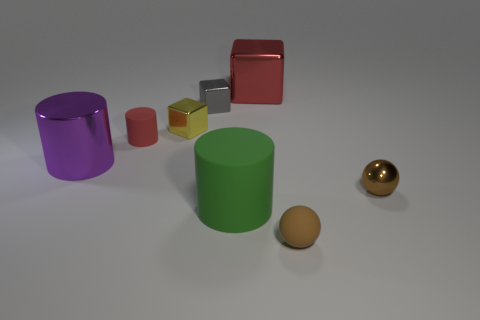There is a brown thing that is in front of the small sphere on the right side of the small brown matte object that is to the right of the red cylinder; what size is it?
Your answer should be very brief. Small. Is the tiny cylinder the same color as the shiny cylinder?
Provide a succinct answer. No. Is there anything else that is the same size as the yellow cube?
Keep it short and to the point. Yes. How many tiny yellow shiny things are behind the red cylinder?
Provide a succinct answer. 1. Are there an equal number of big purple things behind the big green cylinder and large red metal cubes?
Provide a succinct answer. Yes. What number of things are big red rubber cylinders or big purple metal objects?
Make the answer very short. 1. Is there any other thing that has the same shape as the tiny brown rubber thing?
Ensure brevity in your answer.  Yes. What shape is the big object in front of the big object left of the large green cylinder?
Give a very brief answer. Cylinder. What is the shape of the tiny gray object that is the same material as the large cube?
Make the answer very short. Cube. What size is the brown thing that is right of the small brown sphere that is in front of the tiny brown metal sphere?
Offer a very short reply. Small. 